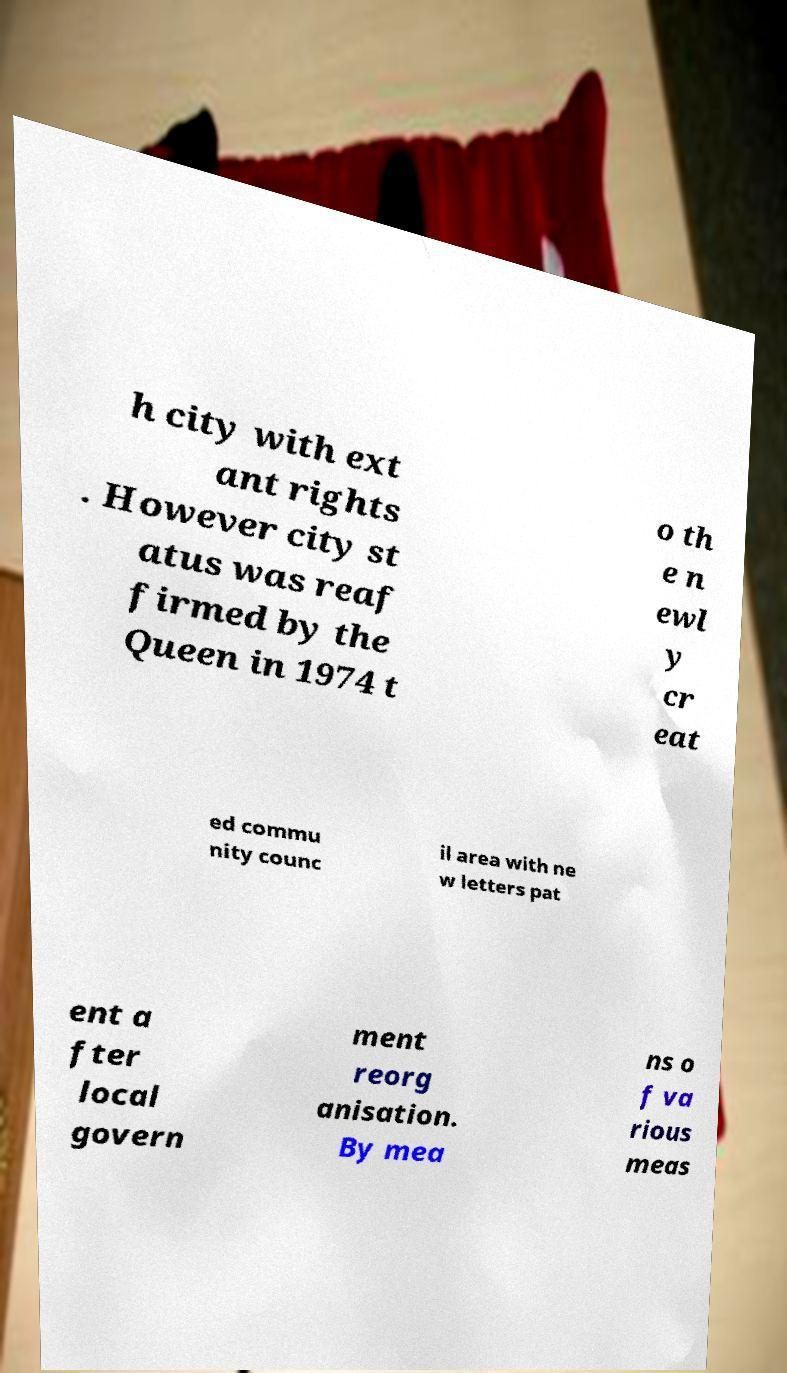Can you read and provide the text displayed in the image?This photo seems to have some interesting text. Can you extract and type it out for me? h city with ext ant rights . However city st atus was reaf firmed by the Queen in 1974 t o th e n ewl y cr eat ed commu nity counc il area with ne w letters pat ent a fter local govern ment reorg anisation. By mea ns o f va rious meas 